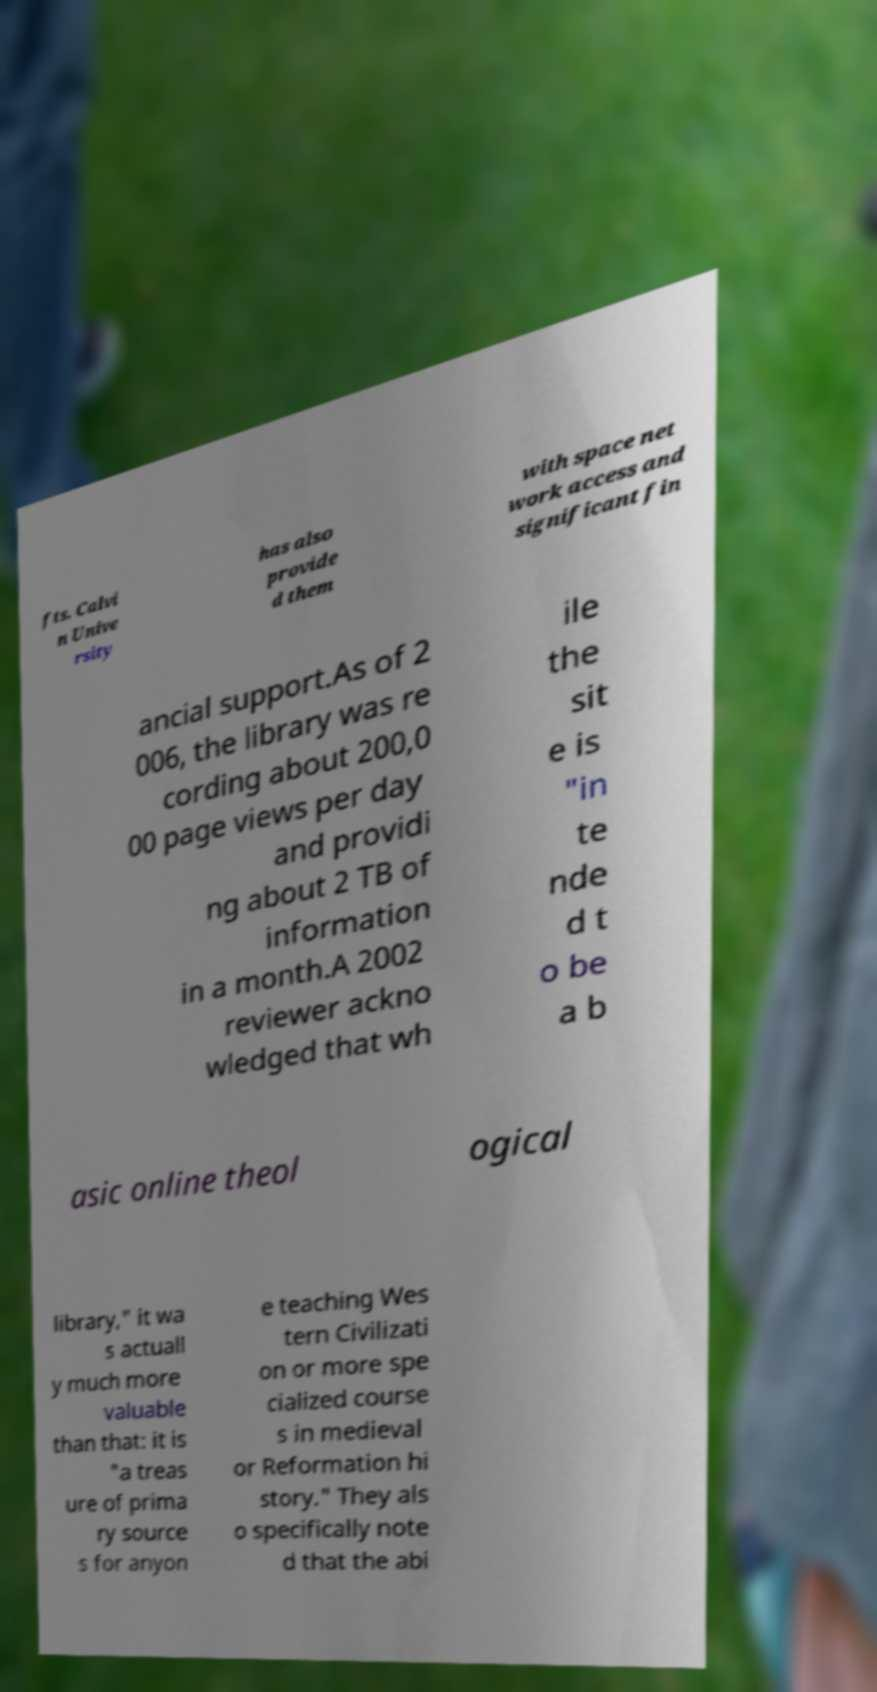Could you assist in decoding the text presented in this image and type it out clearly? fts. Calvi n Unive rsity has also provide d them with space net work access and significant fin ancial support.As of 2 006, the library was re cording about 200,0 00 page views per day and providi ng about 2 TB of information in a month.A 2002 reviewer ackno wledged that wh ile the sit e is "in te nde d t o be a b asic online theol ogical library," it wa s actuall y much more valuable than that: it is "a treas ure of prima ry source s for anyon e teaching Wes tern Civilizati on or more spe cialized course s in medieval or Reformation hi story." They als o specifically note d that the abi 